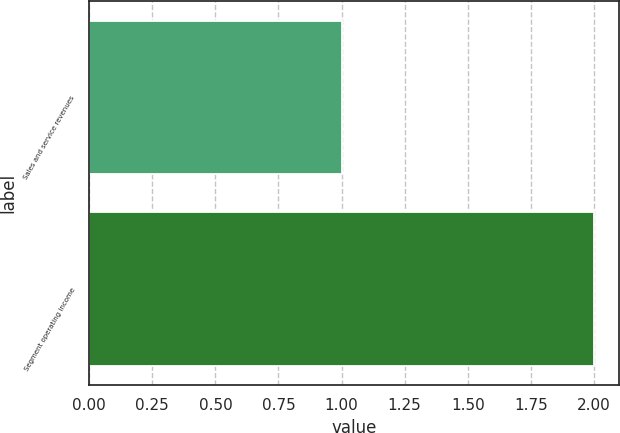Convert chart. <chart><loc_0><loc_0><loc_500><loc_500><bar_chart><fcel>Sales and service revenues<fcel>Segment operating income<nl><fcel>1<fcel>2<nl></chart> 